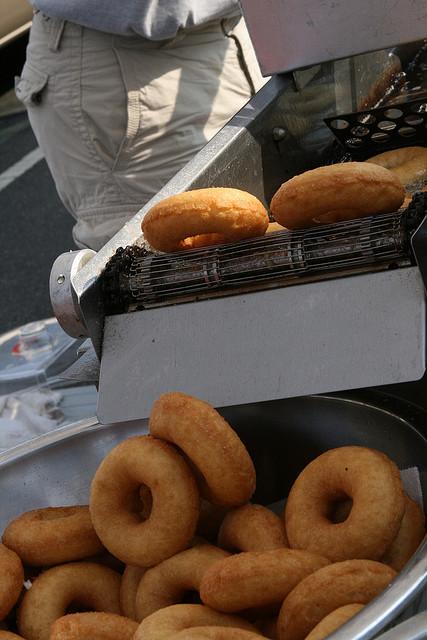Is this a healthy food?
Answer briefly. No. How many donuts are there?
Concise answer only. 20. Are these donuts fried?
Be succinct. Yes. 